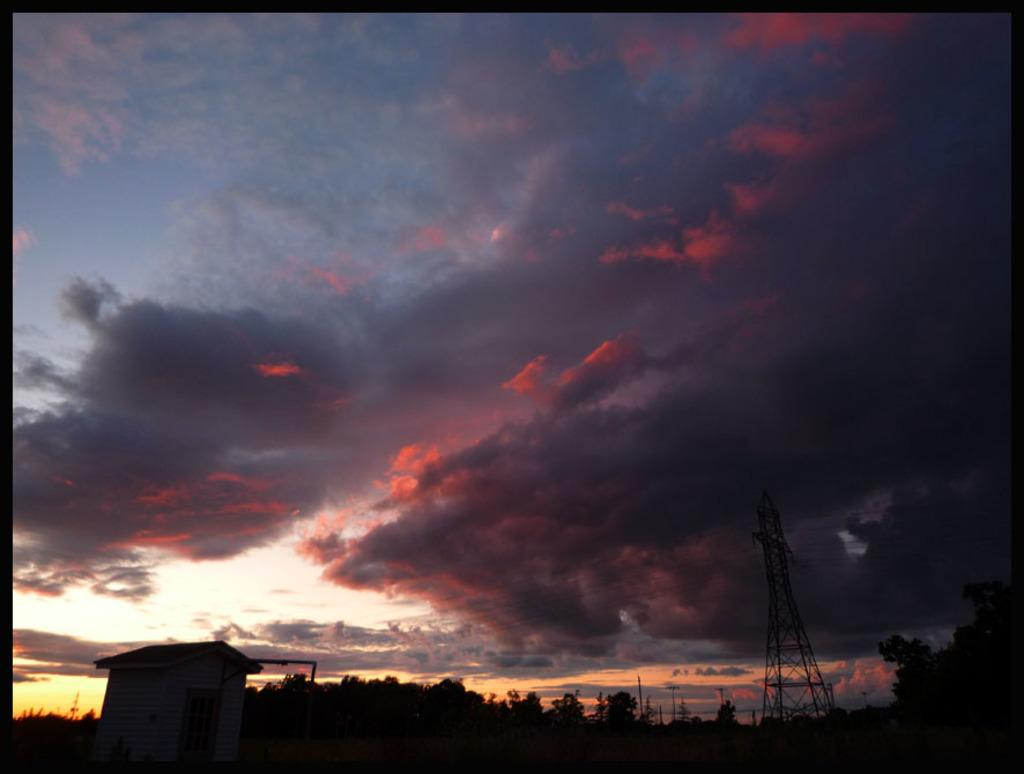Where was the image taken? The image was taken outdoors. What can be seen in the sky in the image? There is a sky with clouds visible in the image. What type of vegetation is present at the bottom of the image? There are many trees and plants at the bottom of the image. What structures can be seen in the image? There is a tower and a hut in the image. Where is the doctor's office located in the image? There is no doctor's office present in the image. What type of error can be seen in the image? There is no error present in the image. 